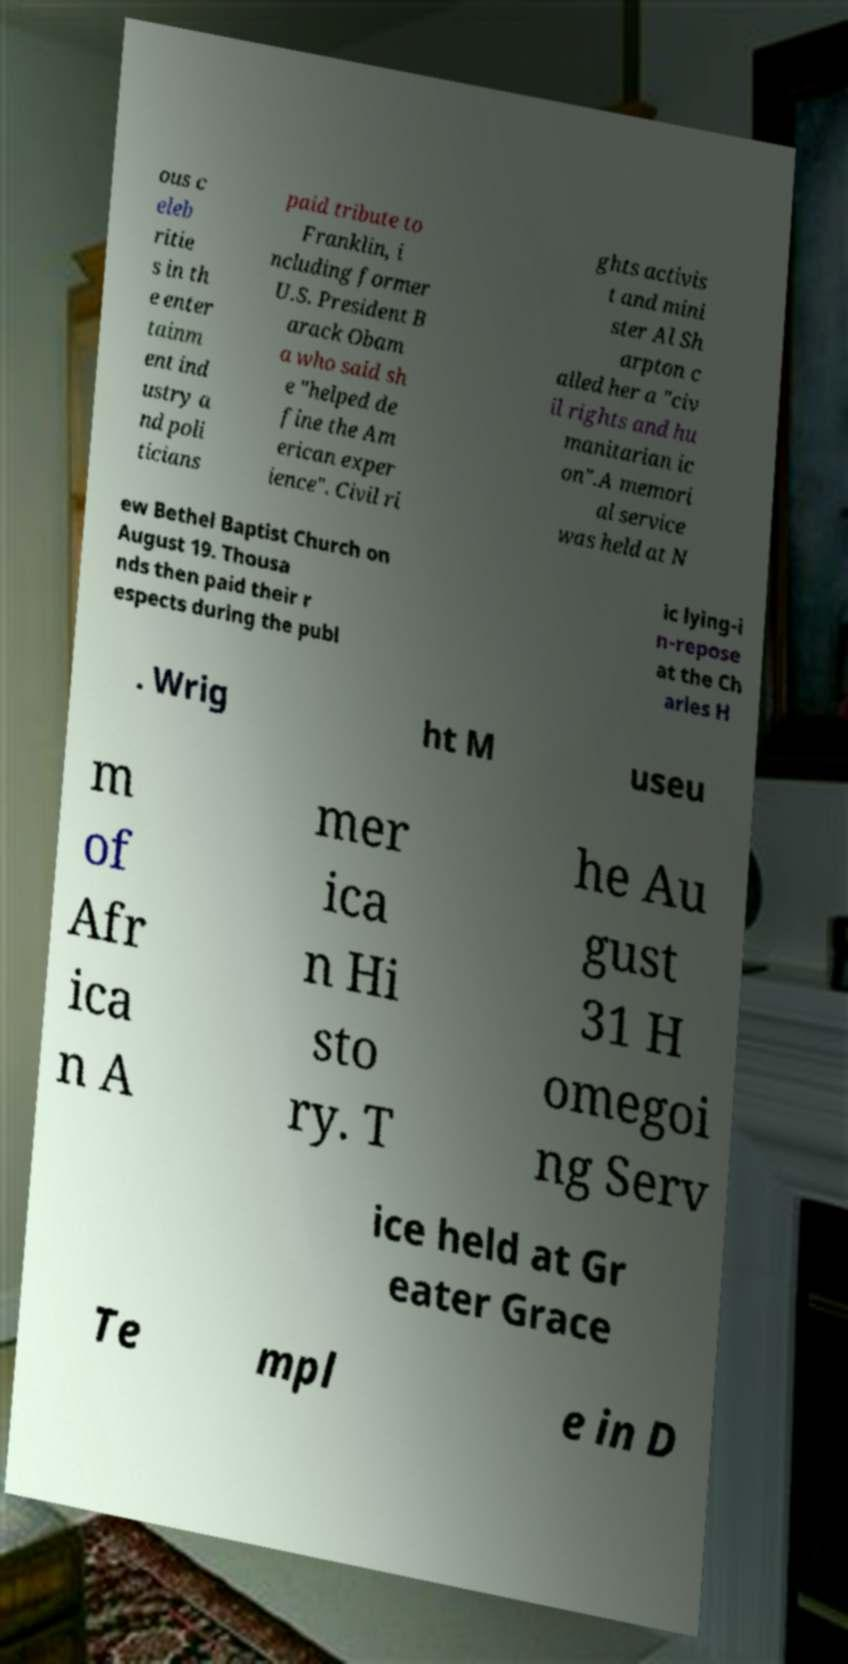Can you accurately transcribe the text from the provided image for me? ous c eleb ritie s in th e enter tainm ent ind ustry a nd poli ticians paid tribute to Franklin, i ncluding former U.S. President B arack Obam a who said sh e "helped de fine the Am erican exper ience". Civil ri ghts activis t and mini ster Al Sh arpton c alled her a "civ il rights and hu manitarian ic on".A memori al service was held at N ew Bethel Baptist Church on August 19. Thousa nds then paid their r espects during the publ ic lying-i n-repose at the Ch arles H . Wrig ht M useu m of Afr ica n A mer ica n Hi sto ry. T he Au gust 31 H omegoi ng Serv ice held at Gr eater Grace Te mpl e in D 